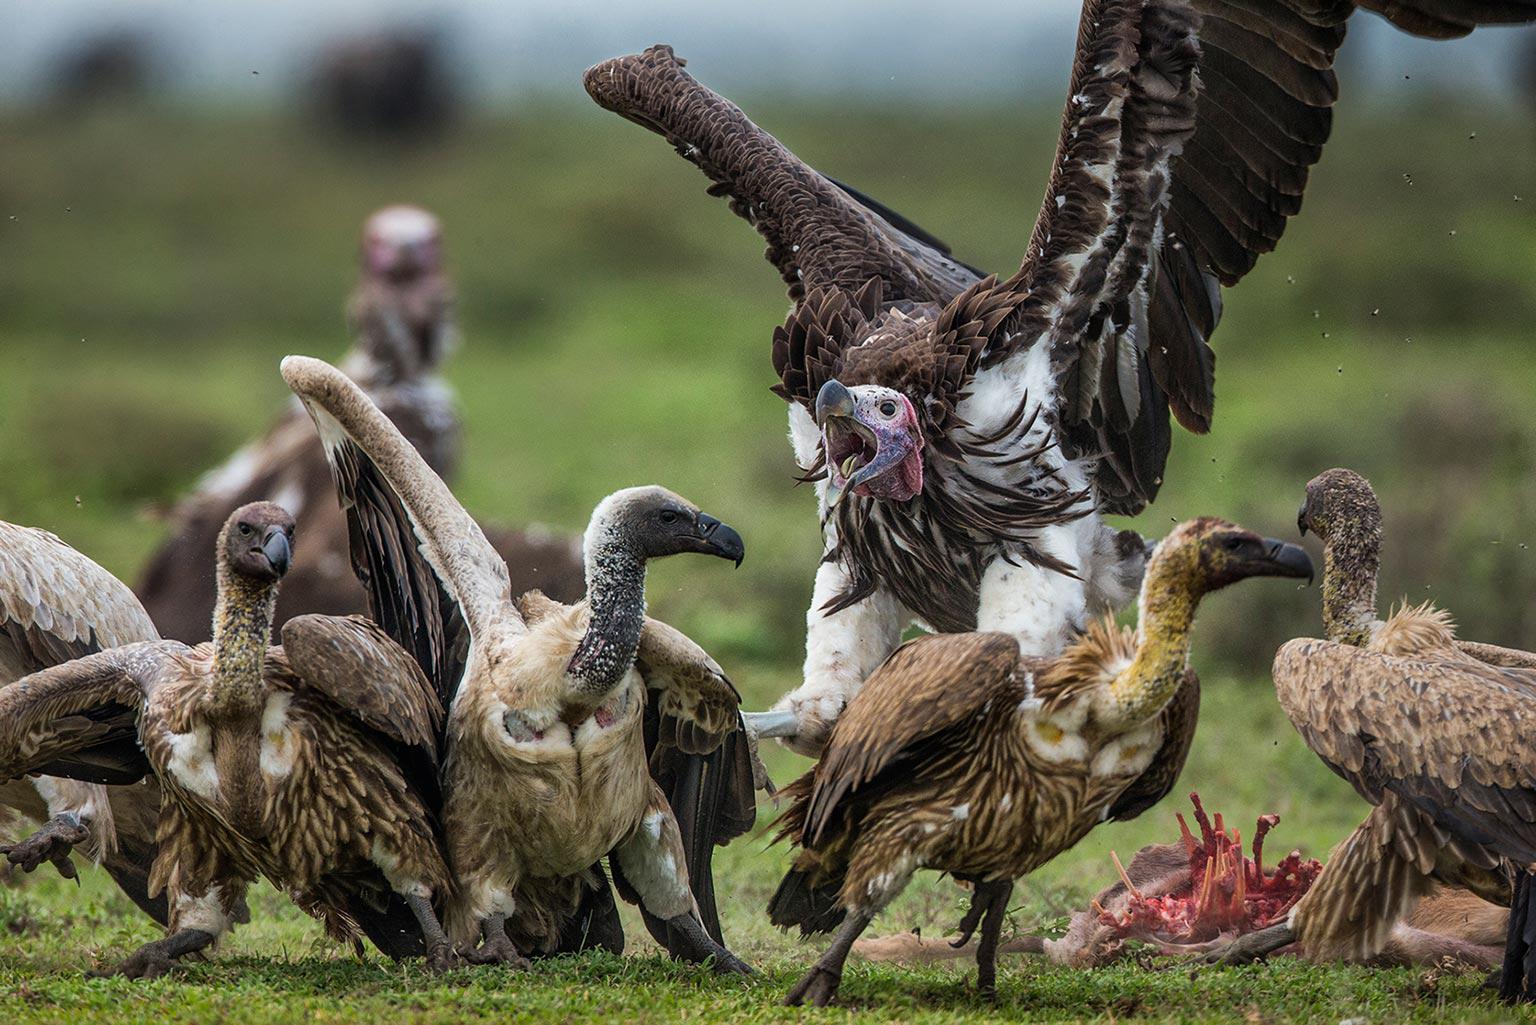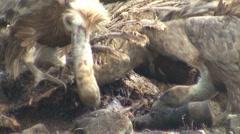The first image is the image on the left, the second image is the image on the right. Given the left and right images, does the statement "In at least one image there is a vulture white and black father flying into the ground with his beak open." hold true? Answer yes or no. Yes. 